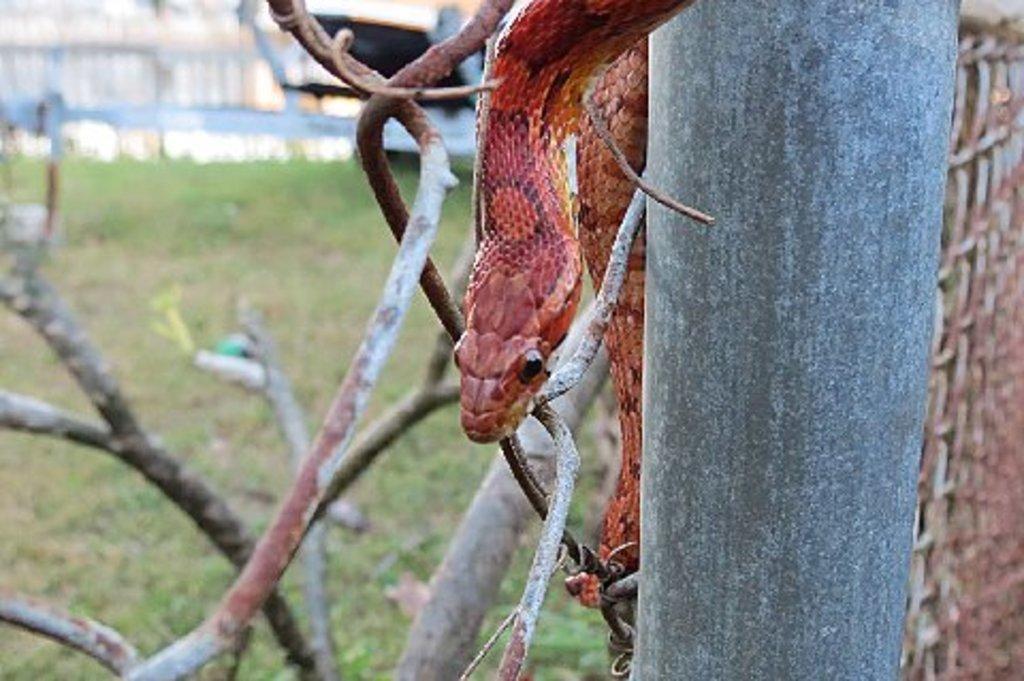How would you summarize this image in a sentence or two? Here in this picture we can see a snake present on a tree and we can see the ground is fully covered with grass and beside the snake we can see a pole present. 